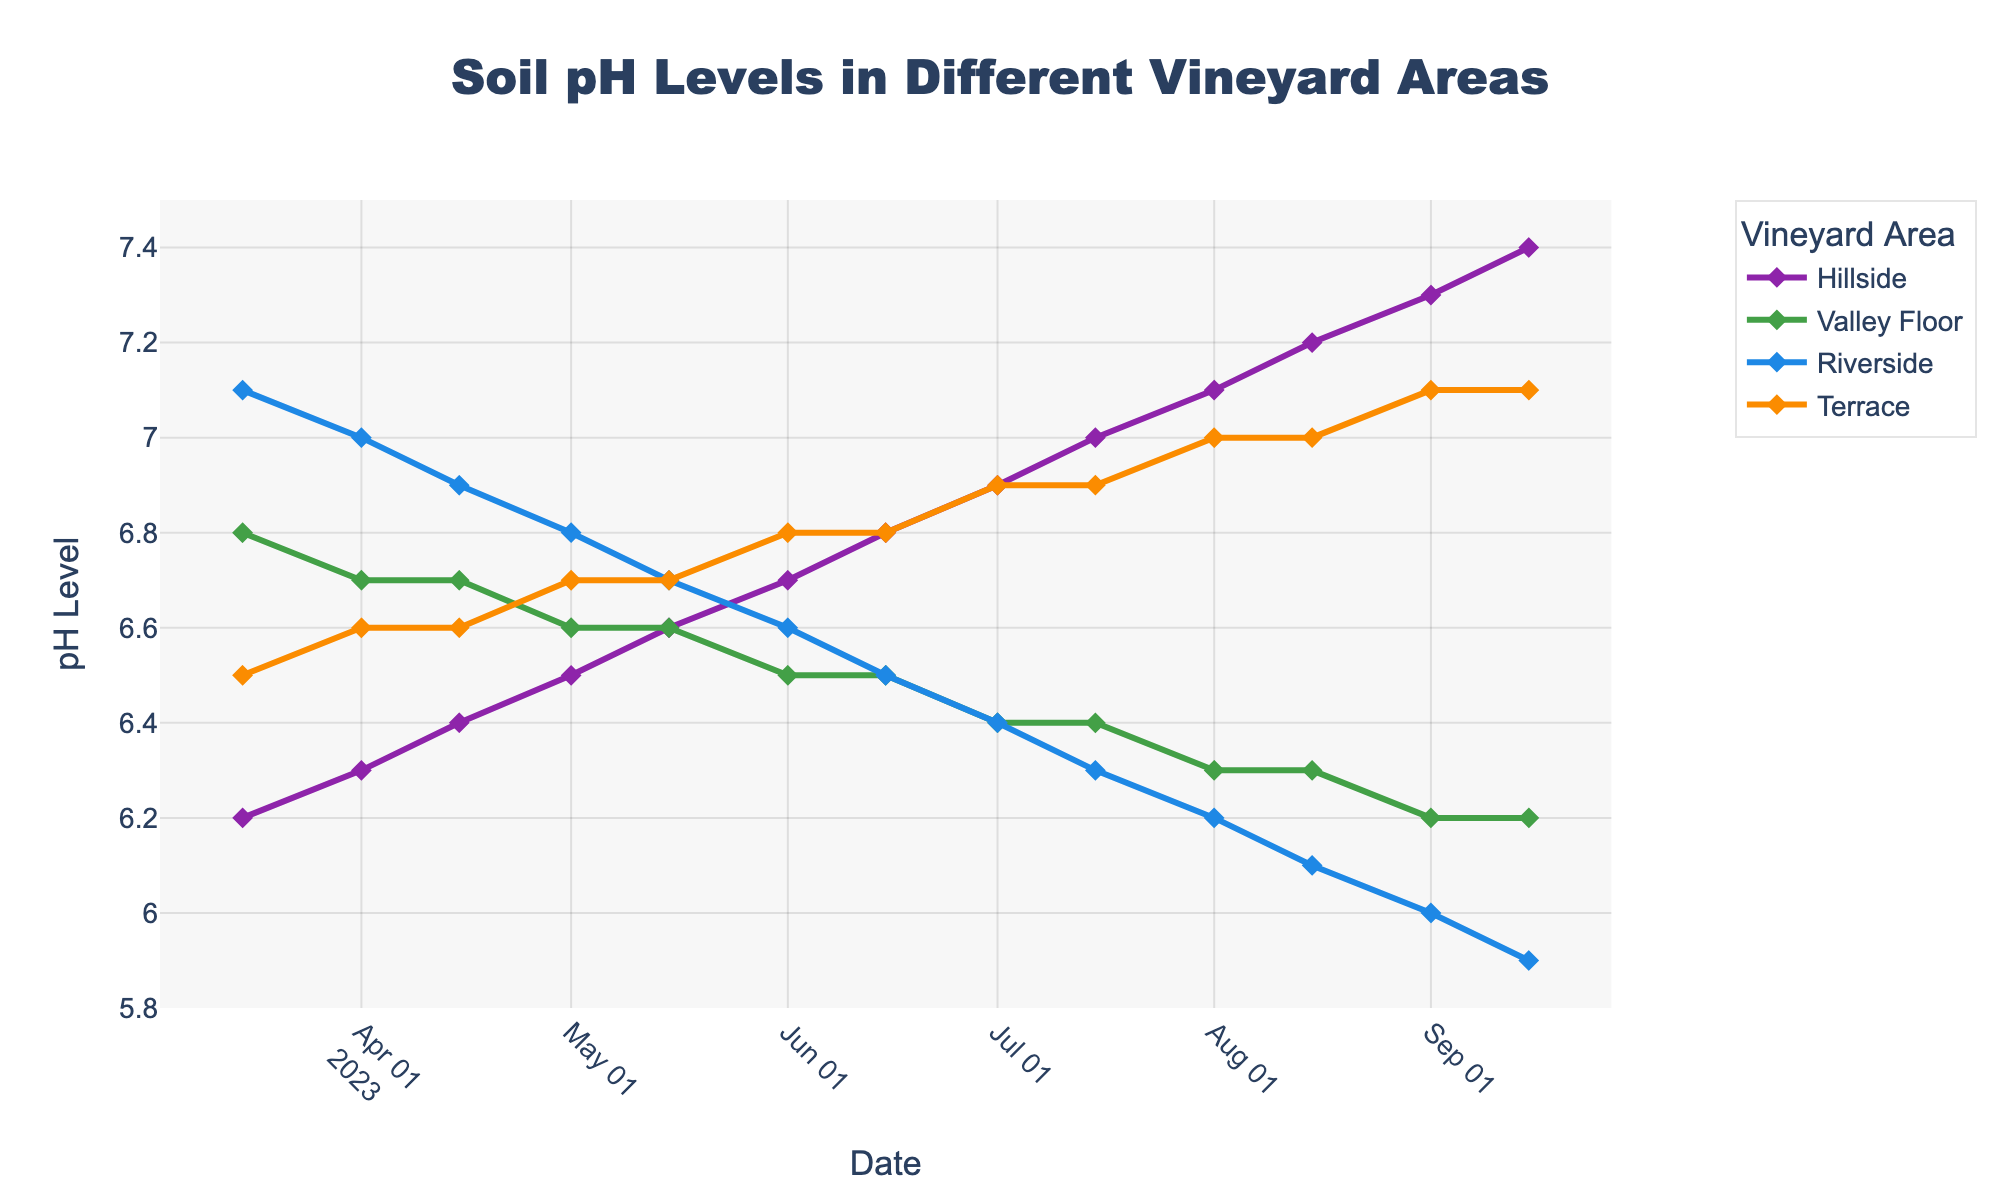1. What is the average soil pH level at Hillside for the first three dates? To find the average soil pH level, sum the pH levels for Hillside on the first three dates and divide by three. The pH levels are 6.2, 6.3, and 6.4. So, (6.2 + 6.3 + 6.4) / 3 = 18.9 / 3 = 6.3
Answer: 6.3 2. By how much did the soil pH level at Riverside change from 2023-03-15 to 2023-09-15? The soil pH level at Riverside on 2023-03-15 is 7.1 and on 2023-09-15 is 5.9. The change is calculated by subtracting the later value from the earlier value: 7.1 - 5.9 = 1.2
Answer: 1.2 3. What is the average decrease in pH level at Valley Floor between each data point from 2023-03-15 to 2023-09-15? Track the decreases: 6.8 to 6.7 (-0.1), 6.7 to 6.7 (0.0), 6.7 to 6.6 (-0.1), 6.6 to 6.6 (0.0), 6.6 to 6.5 (-0.1), 6.5 to 6.5 (0.0), 6.5 to 6.4 (-0.1), 6.4 to 6.4 (0.0), 6.4 to 6.3 (-0.1), 6.3 to 6.3 (0.0), 6.3 to 6.2 (-0.1), 6.2 to 6.2 (0.0), 6.2 to 6.2 (0.0). Sum these values (-0.1 * 6 = -0.6) and divide by the number of changes (13): -0.6 / 13 = -0.04615
Answer: -0.04615 4. Which vineyard area had the highest soil pH level on 2023-08-01? On 2023-08-01, Hillside had a pH level of 7.1, Valley Floor had 6.3, Riverside had 6.2, and Terrace had 7.0. The highest pH level is at Hillside.
Answer: Hillside 5. How does the trend of soil pH at Terrace compare to that at Hillside over the season? Both Hillside and Terrace show an increasing trend in soil pH levels from 2023-03-15 to 2023-09-15. Hillside starts at 6.2 and ends at 7.4, while Terrace starts at 6.5 and ends at 7.1. Both areas see a similar upward trend but with different starting and ending points.
Answer: Both increased, Hillside more 6. Did any vineyard area's soil pH level remain constant for any time periods? If so, which area(s) and what time period(s)? Valley Floor had several periods where the pH level remained constant: 6.7 between 2023-04-01 and 2023-04-15, and 6.6 between 2023-05-01 and 2023-06-01, and 6.5 between 2023-06-01 and 2023-07-01, and 6.4 between 2023-07-01 and 2023-07-15, and 6.3 between 2023-08-01 and 2023-08-15, and again at 6.2 from 2023-09-01 to 2023-09-15.
Answer: Valley Floor, multiple periods 7. What color represents the data line for the Valley Floor area? The line color for Valley Floor in the plot is visually represented in green.
Answer: Green 8. On which dates do the markers on the Hillside line show a soil pH level above 7.0? The marker for Hillside shows soil pH levels above 7.0 on dates from 2023-08-01 to 2023-09-15.
Answer: 2023-08-01, 2023-08-15, 2023-09-01, 2023-09-15 9. How many markers, in total, are used to represent the soil pH levels for the Terrace area over the whole date range? Each date in the data is marked, and there are 13 dates in the given range. Therefore, there are 13 markers used.
Answer: 13 10. Between which two dates was the greatest drop in pH level for Riverside observed visually? Viewing the chart, the largest visual drop in pH for Riverside occurred between 2023-03-15 and 2023-09-15, corresponding to the dates 2023-09-01 and 2023-09-15. The pH dropped from 6.0 to 5.9.
Answer: 2023-09-01 to 2023-09-15 